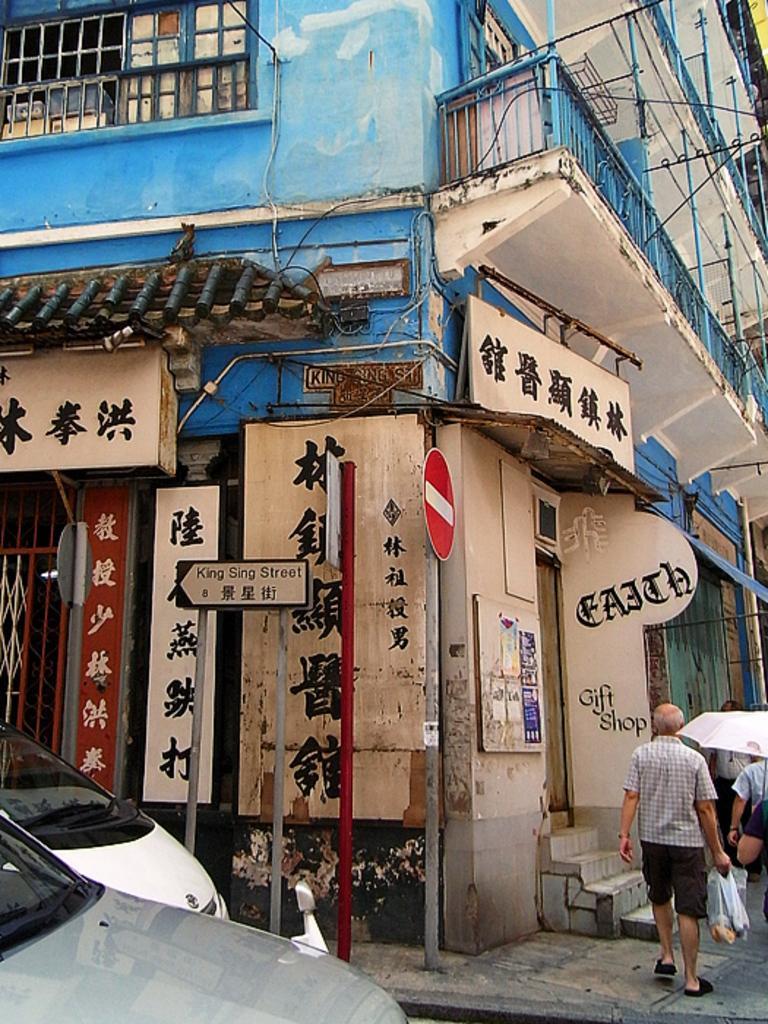In one or two sentences, can you explain what this image depicts? In this image I can see the vehicles on the road. To the side I can see few people walking. I can see one person holding the bags. In the background I can see the building and there are many boards attached. 